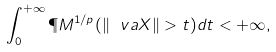Convert formula to latex. <formula><loc_0><loc_0><loc_500><loc_500>\int _ { 0 } ^ { + \infty } \P M ^ { 1 / p } ( \| \ v a X \| > t ) d t < + \infty ,</formula> 